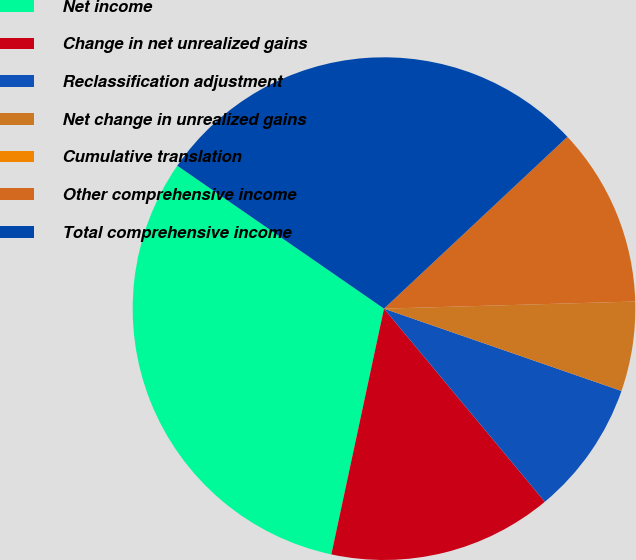<chart> <loc_0><loc_0><loc_500><loc_500><pie_chart><fcel>Net income<fcel>Change in net unrealized gains<fcel>Reclassification adjustment<fcel>Net change in unrealized gains<fcel>Cumulative translation<fcel>Other comprehensive income<fcel>Total comprehensive income<nl><fcel>31.27%<fcel>14.41%<fcel>8.64%<fcel>5.76%<fcel>0.0%<fcel>11.53%<fcel>28.39%<nl></chart> 